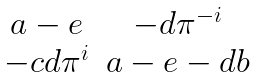<formula> <loc_0><loc_0><loc_500><loc_500>\begin{matrix} a - e & - d \pi ^ { - i } \\ - c d \pi ^ { i } & a - e - d b \end{matrix}</formula> 